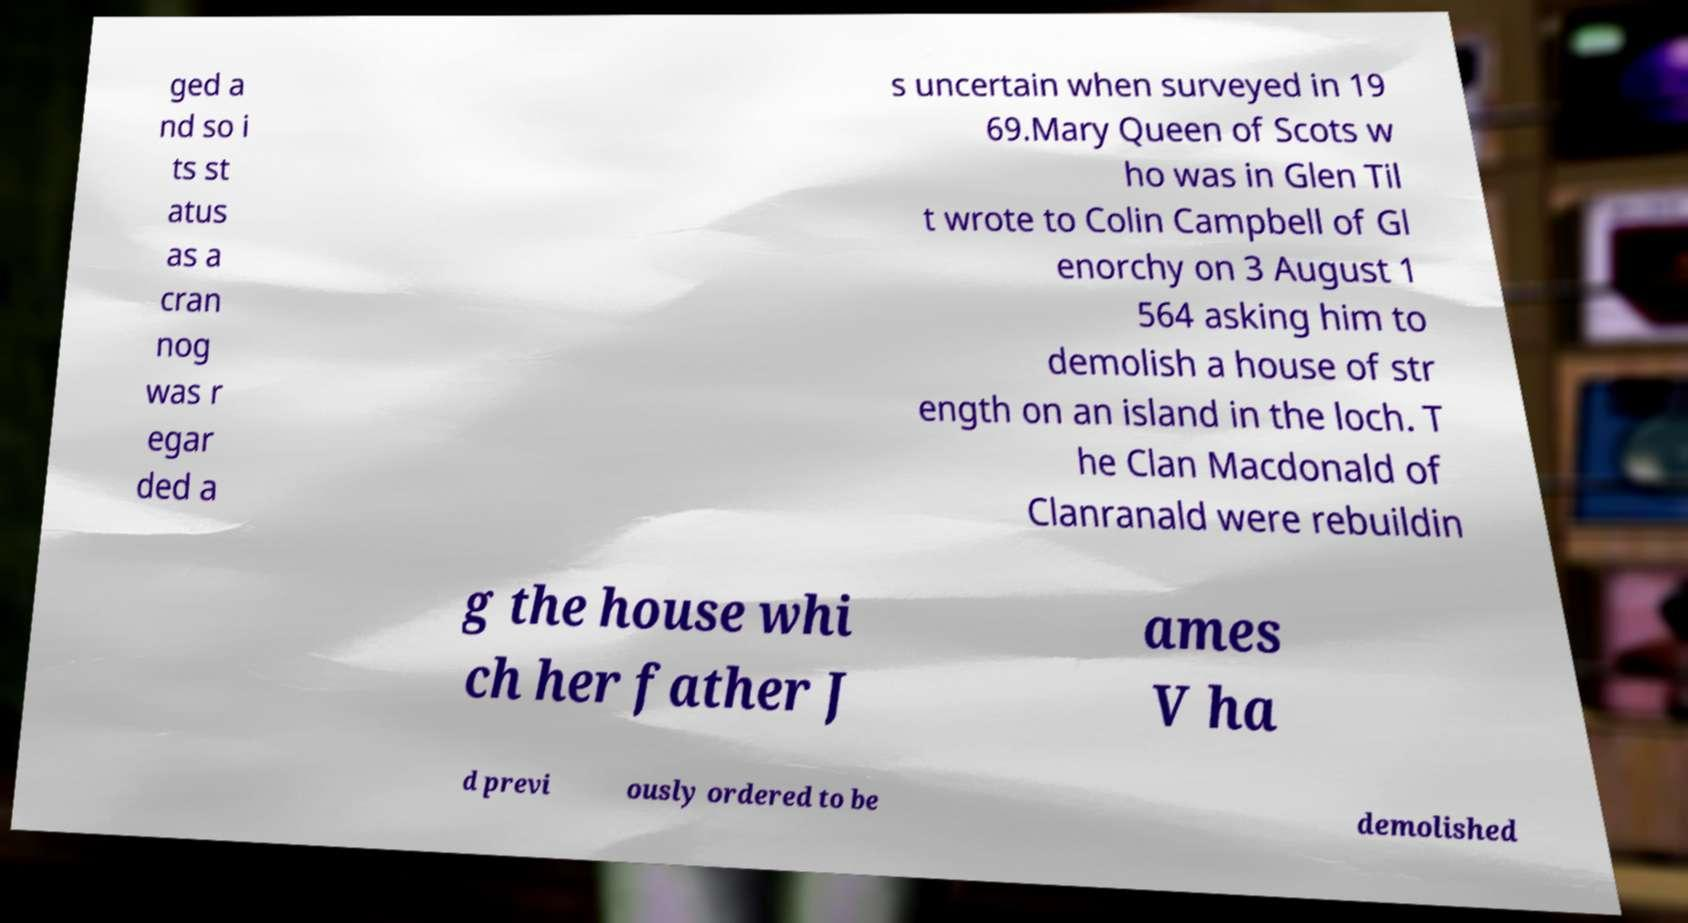Could you extract and type out the text from this image? ged a nd so i ts st atus as a cran nog was r egar ded a s uncertain when surveyed in 19 69.Mary Queen of Scots w ho was in Glen Til t wrote to Colin Campbell of Gl enorchy on 3 August 1 564 asking him to demolish a house of str ength on an island in the loch. T he Clan Macdonald of Clanranald were rebuildin g the house whi ch her father J ames V ha d previ ously ordered to be demolished 